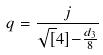Convert formula to latex. <formula><loc_0><loc_0><loc_500><loc_500>q = \frac { j } { \sqrt { [ } 4 ] { - \frac { d _ { 3 } } { 8 } } }</formula> 